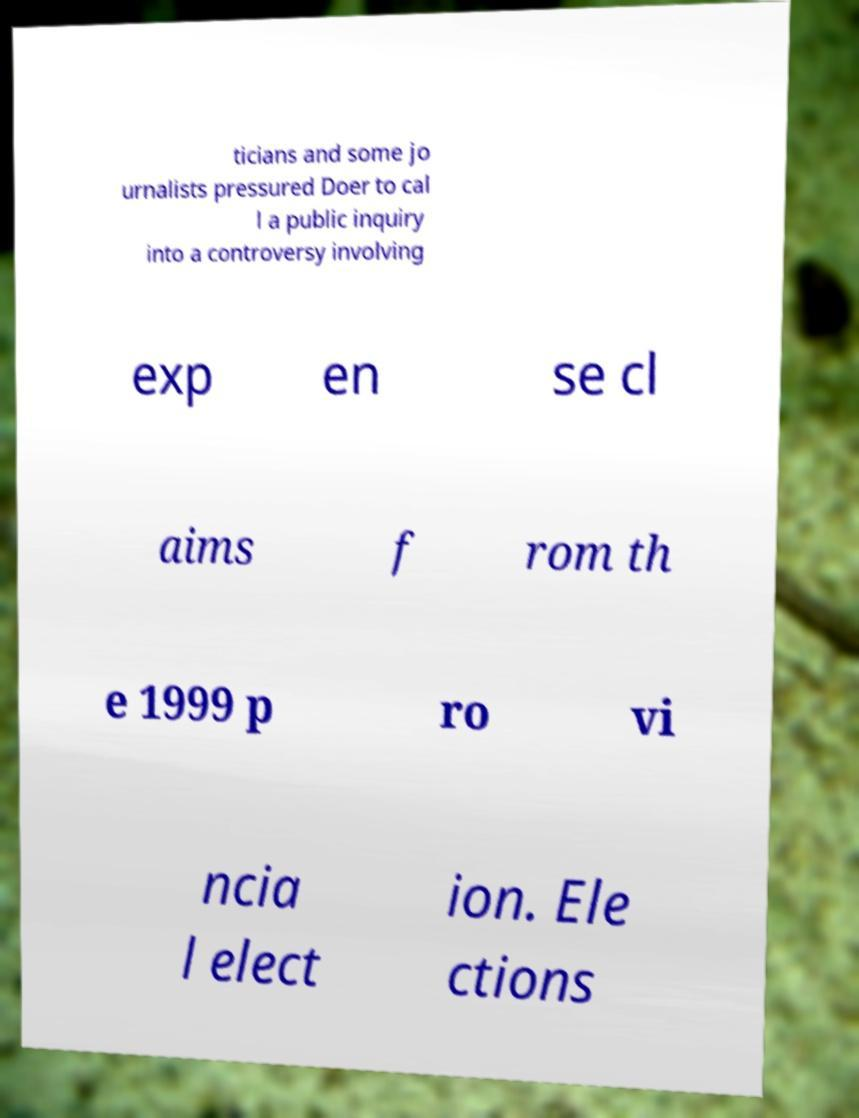There's text embedded in this image that I need extracted. Can you transcribe it verbatim? ticians and some jo urnalists pressured Doer to cal l a public inquiry into a controversy involving exp en se cl aims f rom th e 1999 p ro vi ncia l elect ion. Ele ctions 